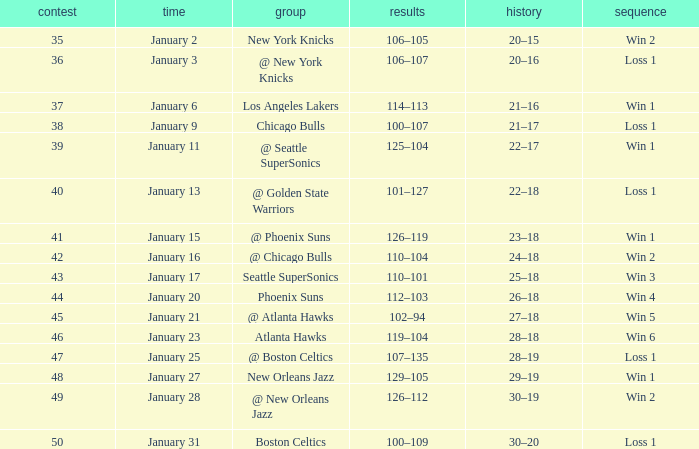What Game had a Score of 129–105? 48.0. 